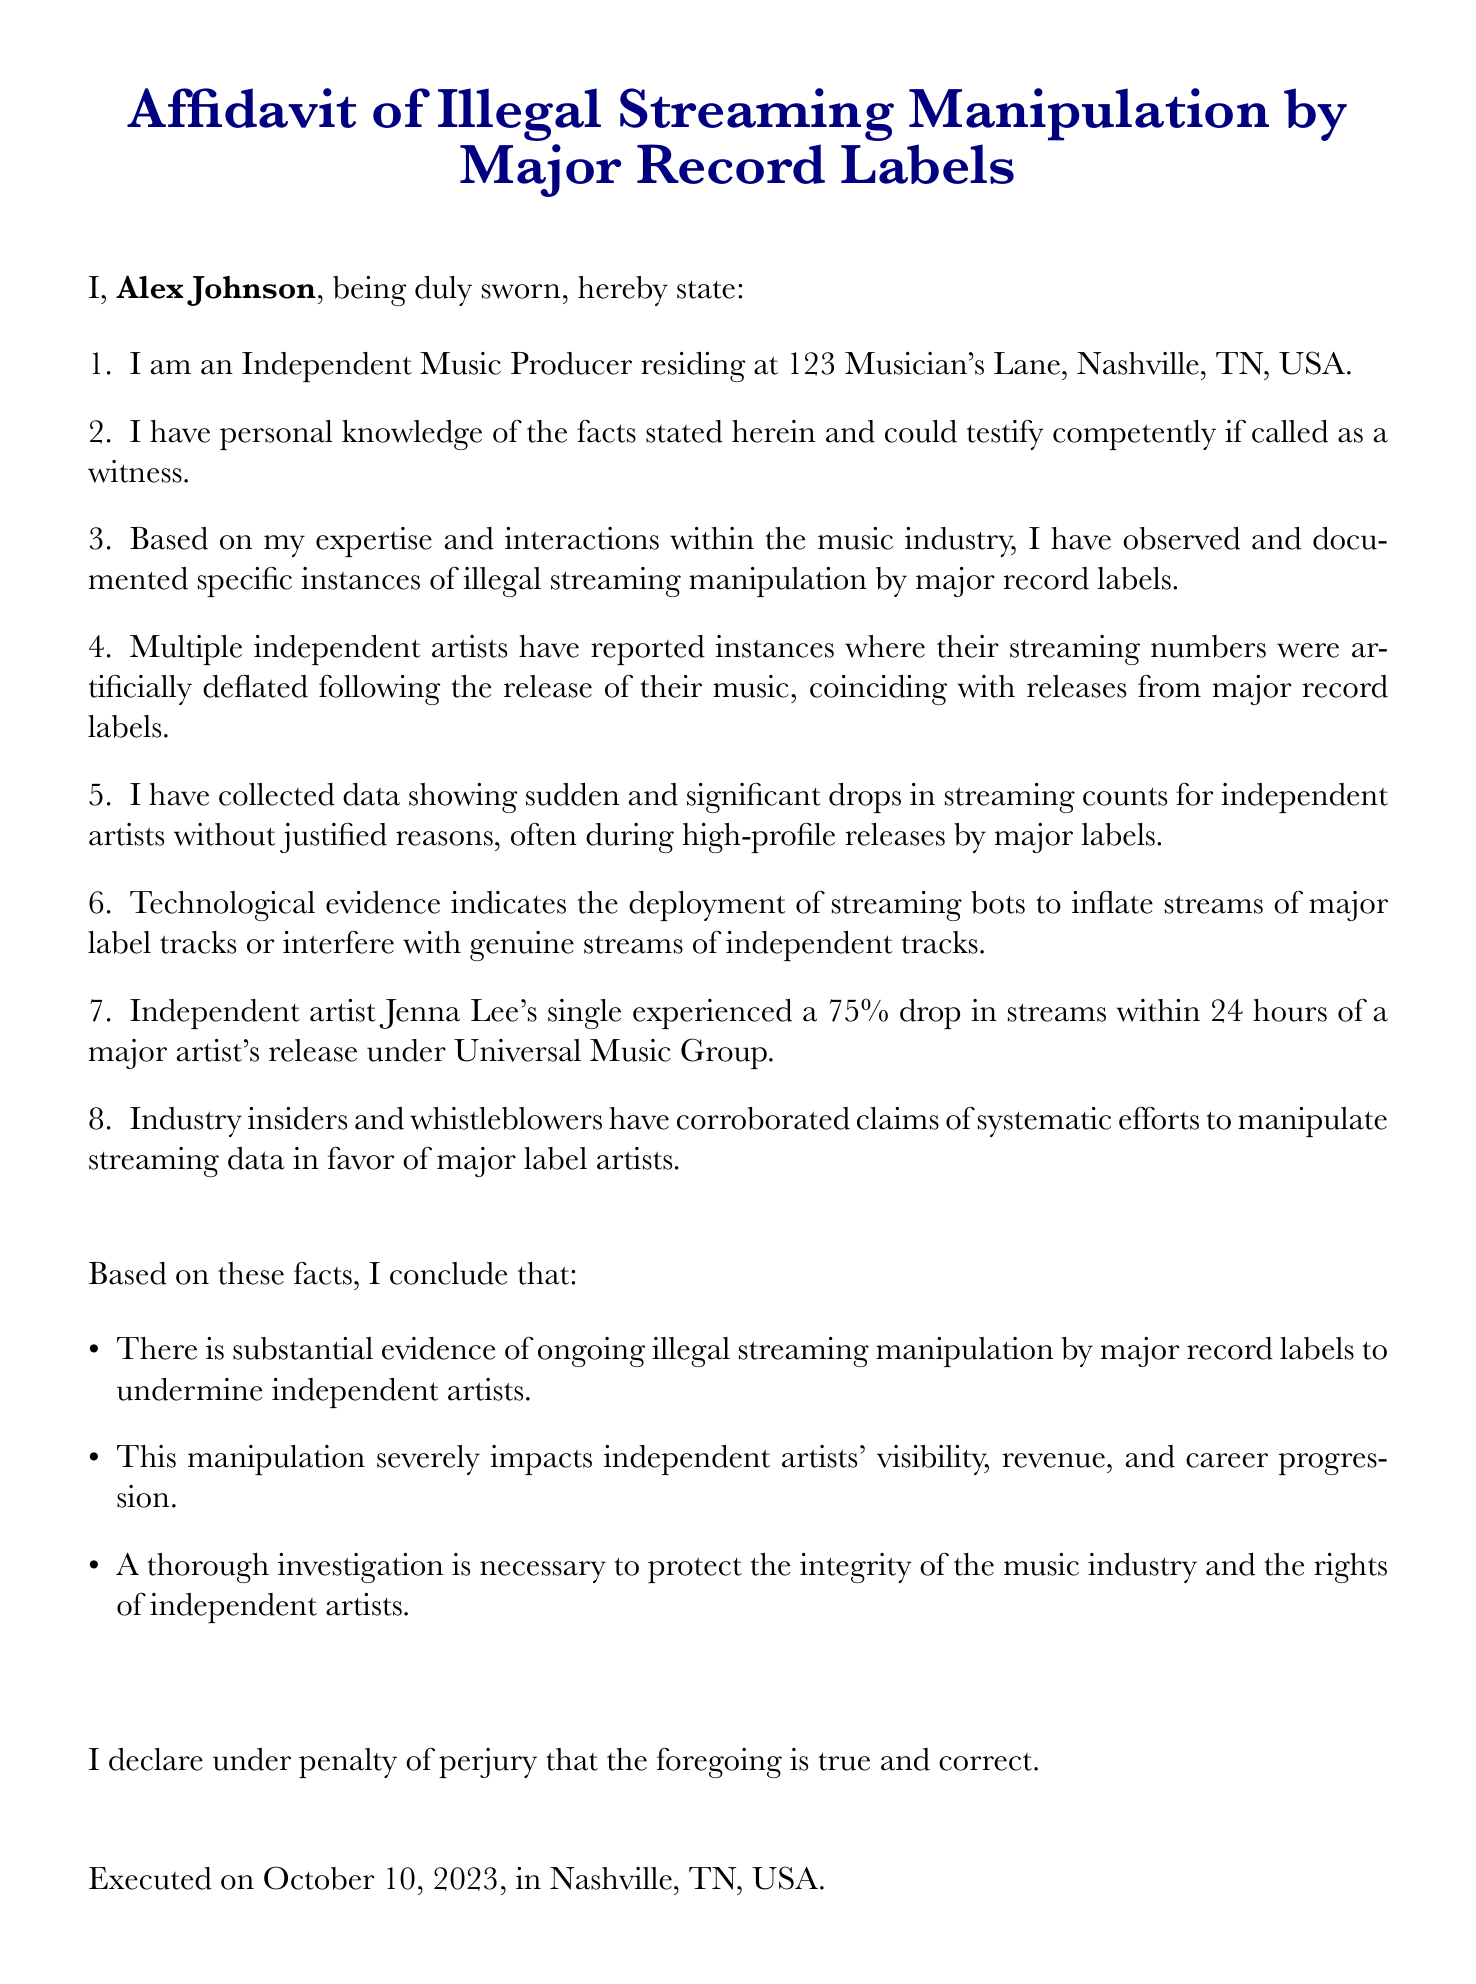What is the name of the affiant? The affiant is identified as Alex Johnson in the document.
Answer: Alex Johnson Where does Alex Johnson reside? The document specifies the location where Alex Johnson resides, which is 123 Musician's Lane, Nashville, TN, USA.
Answer: 123 Musician's Lane, Nashville, TN, USA On what date was the affidavit executed? The document states that the affidavit was executed on October 10, 2023.
Answer: October 10, 2023 What percentage drop in streams did Jenna Lee's single experience? The document mentions that Jenna Lee's single experienced a 75% drop in streams.
Answer: 75% What major record label is mentioned in connection with Jenna Lee's single? The affidavit indicates that Jenna Lee's single had a notable incident related to Universal Music Group.
Answer: Universal Music Group What impact does the affidavit claim manipulation has on independent artists? The affiant states that manipulation severely impacts independent artists' visibility, revenue, and career progression.
Answer: Visibility, revenue, and career progression What kind of evidence does the affiant claim to have collected? The affiant claims to have collected data showing significant drops in streaming counts for independent artists.
Answer: Data showing significant drops Is there a call for investigation in the affidavit? The document includes a conclusion that there is a necessity for a thorough investigation to protect independent artists.
Answer: Yes 